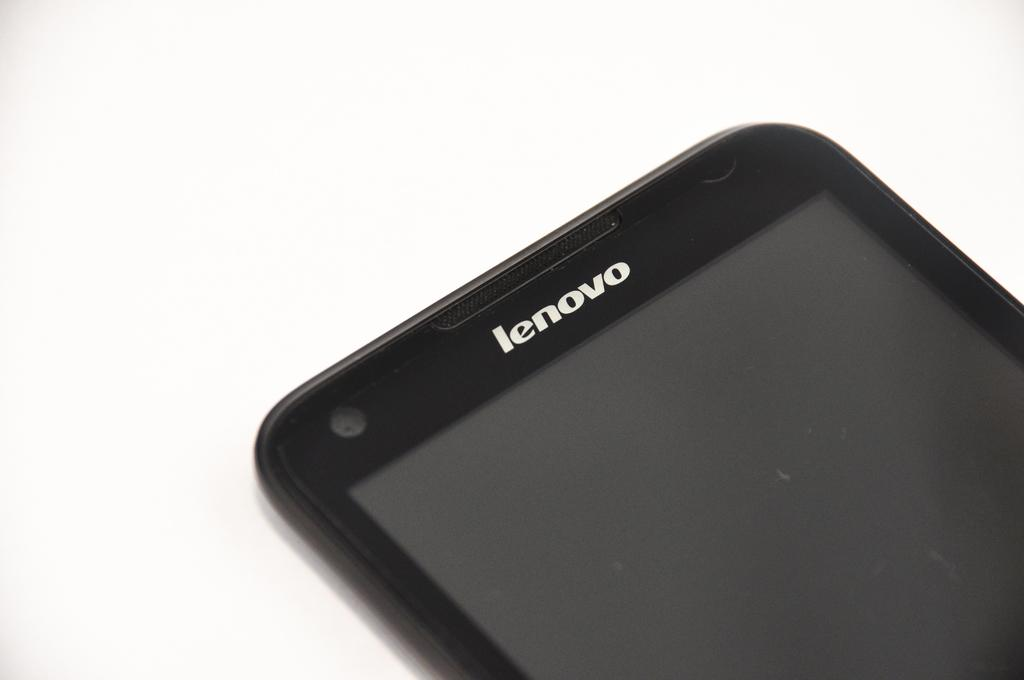<image>
Render a clear and concise summary of the photo. The brand name of the device is called "lenovo." 